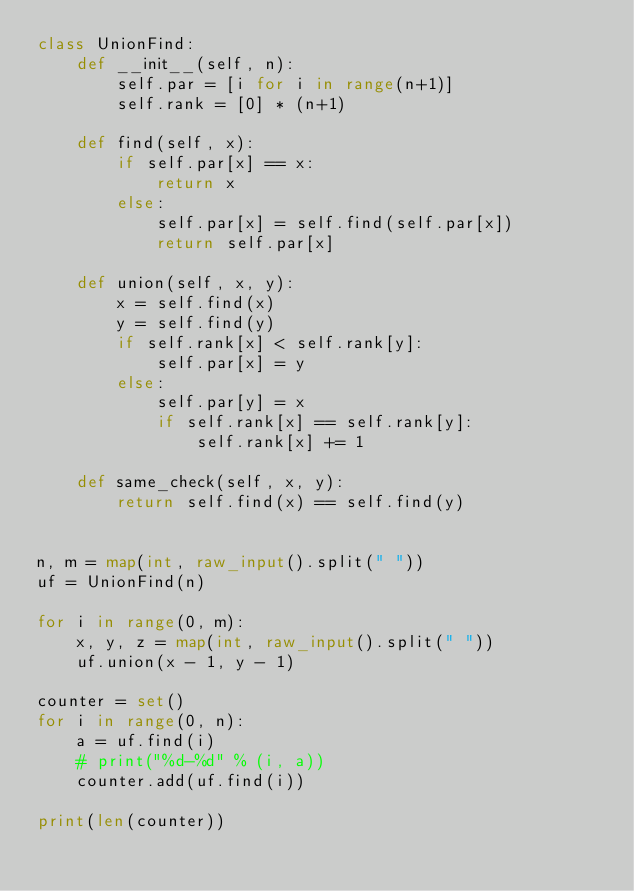Convert code to text. <code><loc_0><loc_0><loc_500><loc_500><_Python_>class UnionFind:
    def __init__(self, n):
        self.par = [i for i in range(n+1)]
        self.rank = [0] * (n+1)

    def find(self, x):
        if self.par[x] == x:
            return x
        else:
            self.par[x] = self.find(self.par[x])
            return self.par[x]

    def union(self, x, y):
        x = self.find(x)
        y = self.find(y)
        if self.rank[x] < self.rank[y]:
            self.par[x] = y
        else:
            self.par[y] = x
            if self.rank[x] == self.rank[y]:
                self.rank[x] += 1

    def same_check(self, x, y):
        return self.find(x) == self.find(y)


n, m = map(int, raw_input().split(" "))
uf = UnionFind(n)

for i in range(0, m):
    x, y, z = map(int, raw_input().split(" "))
    uf.union(x - 1, y - 1)

counter = set()
for i in range(0, n):
    a = uf.find(i)
    # print("%d-%d" % (i, a))
    counter.add(uf.find(i))

print(len(counter))
</code> 